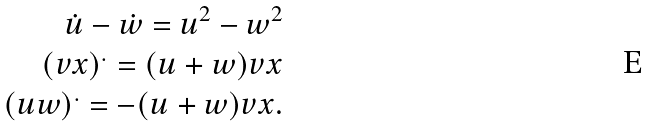Convert formula to latex. <formula><loc_0><loc_0><loc_500><loc_500>\dot { u } - \dot { w } = u ^ { 2 } - w ^ { 2 } \\ ( v x ) ^ { . } = ( u + w ) v x \\ ( u w ) ^ { . } = - ( u + w ) v x .</formula> 